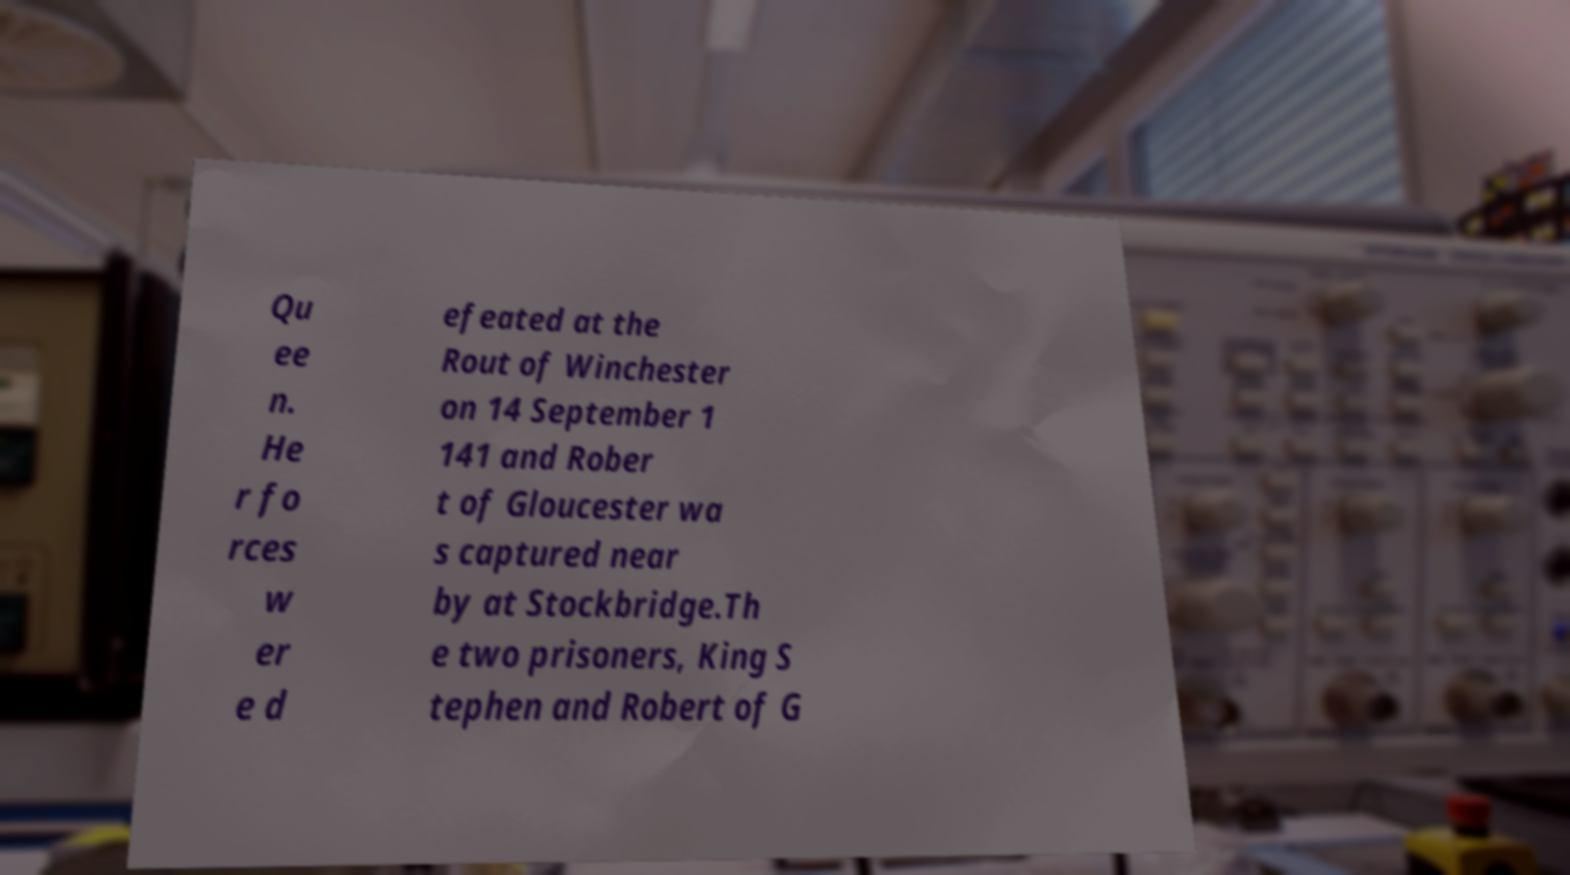Could you assist in decoding the text presented in this image and type it out clearly? Qu ee n. He r fo rces w er e d efeated at the Rout of Winchester on 14 September 1 141 and Rober t of Gloucester wa s captured near by at Stockbridge.Th e two prisoners, King S tephen and Robert of G 